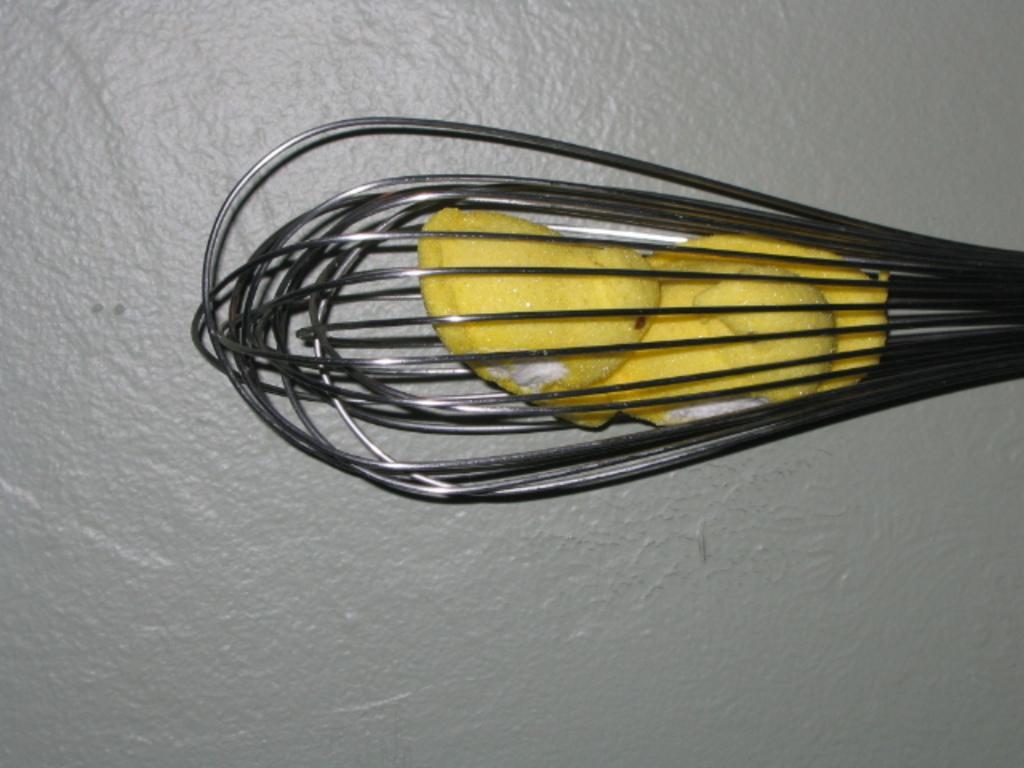Please provide a concise description of this image. In this image, we can see a utensil with some object is placed on the surface. 